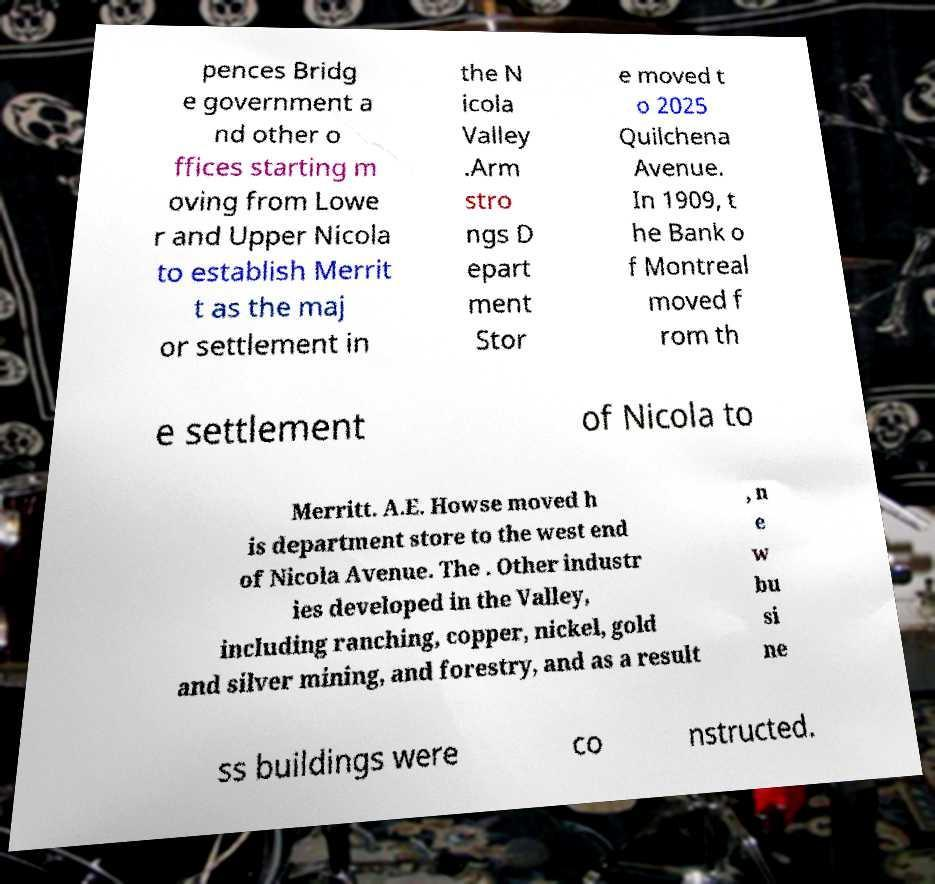For documentation purposes, I need the text within this image transcribed. Could you provide that? pences Bridg e government a nd other o ffices starting m oving from Lowe r and Upper Nicola to establish Merrit t as the maj or settlement in the N icola Valley .Arm stro ngs D epart ment Stor e moved t o 2025 Quilchena Avenue. In 1909, t he Bank o f Montreal moved f rom th e settlement of Nicola to Merritt. A.E. Howse moved h is department store to the west end of Nicola Avenue. The . Other industr ies developed in the Valley, including ranching, copper, nickel, gold and silver mining, and forestry, and as a result , n e w bu si ne ss buildings were co nstructed. 